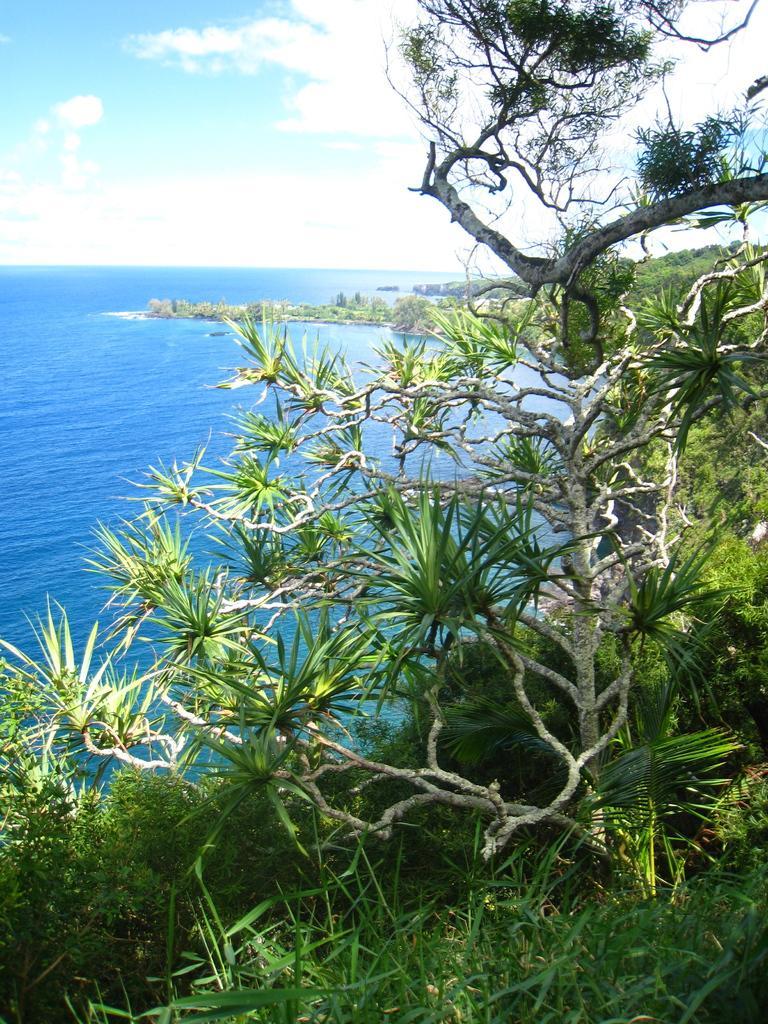Can you describe this image briefly? In the foreground of this image, there is grass and trees. In the background, there is water, sky and the cloud. 